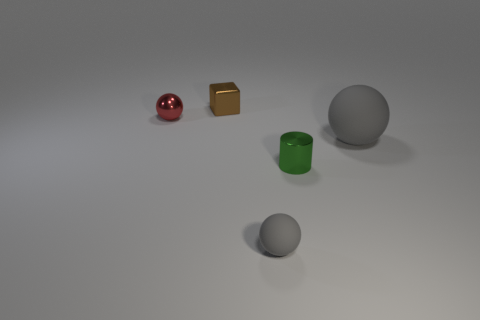Do the small red sphere and the tiny gray ball have the same material?
Make the answer very short. No. Is the number of brown metal things to the right of the brown object the same as the number of tiny gray things?
Your answer should be very brief. No. What number of big balls have the same material as the tiny gray ball?
Provide a short and direct response. 1. Are there fewer metal spheres than small green rubber objects?
Your answer should be very brief. No. There is a thing in front of the metallic cylinder; does it have the same color as the large rubber ball?
Your answer should be very brief. Yes. There is a ball in front of the gray object that is behind the tiny gray matte ball; what number of tiny red metal things are behind it?
Keep it short and to the point. 1. What number of gray matte things are behind the metal sphere?
Offer a terse response. 0. There is a big thing that is the same shape as the tiny gray matte object; what is its color?
Provide a succinct answer. Gray. What is the object that is both behind the green metallic thing and in front of the metal sphere made of?
Offer a terse response. Rubber. Is the size of the object that is to the left of the brown object the same as the small shiny cylinder?
Keep it short and to the point. Yes. 